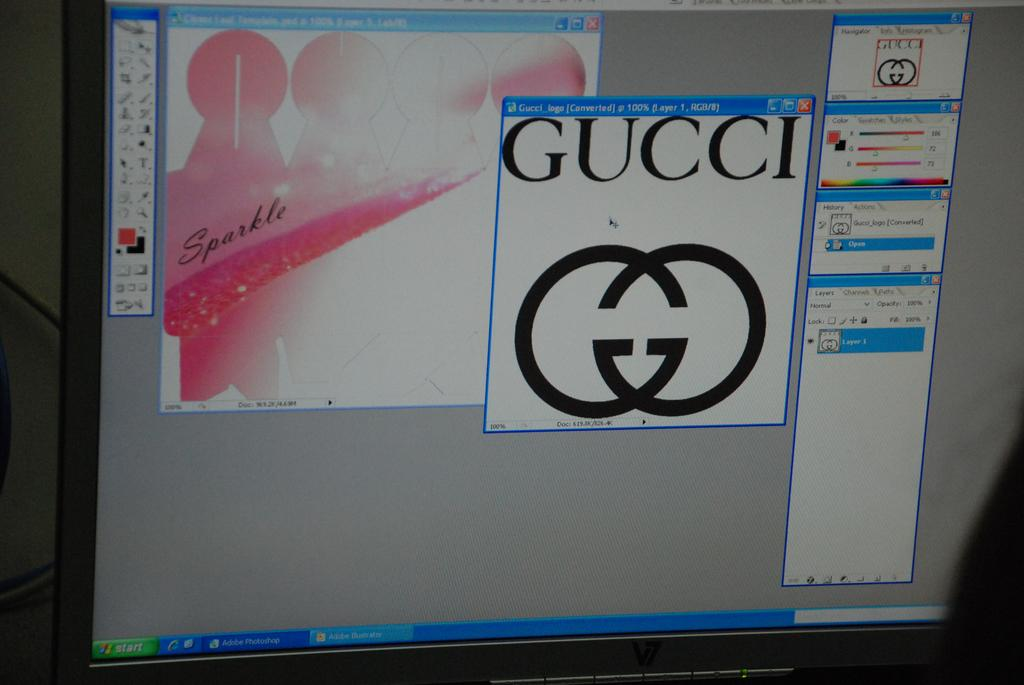What electronic device is visible in the image? There is a computer monitor in the image. What type of advertisement is displayed on the computer monitor in the image? There is no advertisement displayed on the computer monitor in the image; only the monitor itself is visible. Can you see the thumb of the person using the computer monitor in the image? There is no person or thumb visible in the image; only the computer monitor is present in the image. 